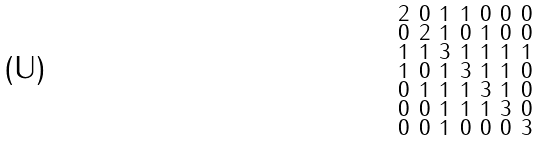Convert formula to latex. <formula><loc_0><loc_0><loc_500><loc_500>\begin{smallmatrix} 2 & 0 & 1 & 1 & 0 & 0 & 0 \\ 0 & 2 & 1 & 0 & 1 & 0 & 0 \\ 1 & 1 & 3 & 1 & 1 & 1 & 1 \\ 1 & 0 & 1 & 3 & 1 & 1 & 0 \\ 0 & 1 & 1 & 1 & 3 & 1 & 0 \\ 0 & 0 & 1 & 1 & 1 & 3 & 0 \\ 0 & 0 & 1 & 0 & 0 & 0 & 3 \end{smallmatrix}</formula> 